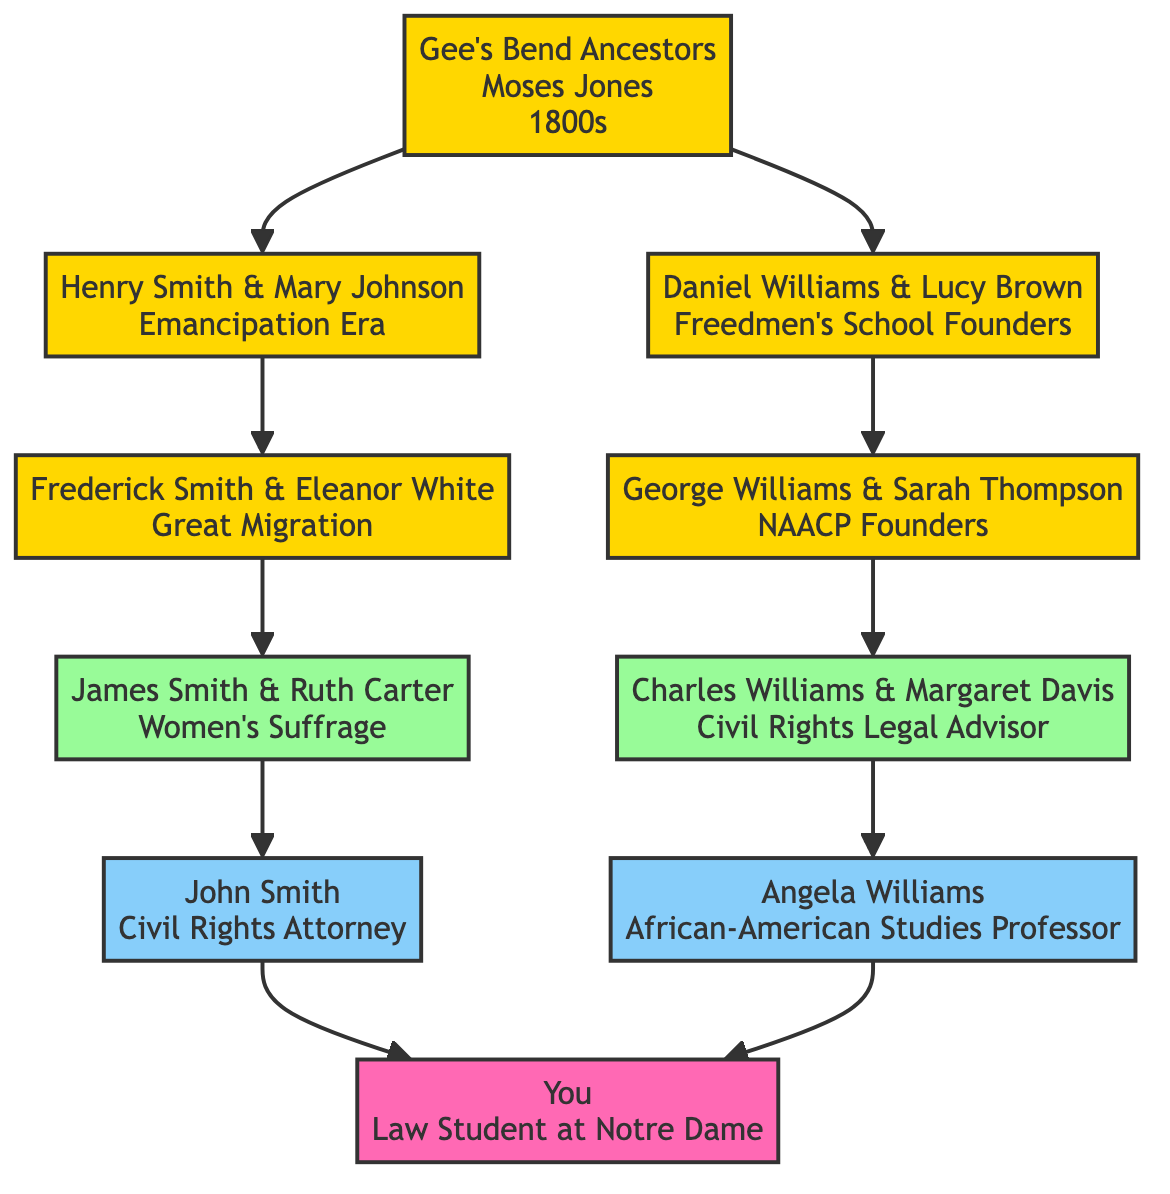What notable achievement is associated with John Smith? The diagram shows that John Smith is a Civil Rights attorney involved in landmark cases for racial equality. This information is derived from his individual node within the Parents section of the tree.
Answer: Civil Rights attorney Who are the Great-Grandparents on the maternal side? The Great-Grandparents section lists George Williams and Sarah Thompson as the maternal Great-Grandparents. You can find this by looking at the maternal branch under the Great-Grandparents in the diagram.
Answer: George Williams and Sarah Thompson How many nodes are in the diagram? The diagram includes 11 nodes in total, representing the different generations and notable individuals in the family tree. This total is calculated by counting each individual and merged node in the visual representation.
Answer: 11 What is the notable achievement of Ruth Carter? The diagram indicates that Ruth Carter was involved in the women’s suffrage movement and was an early voting rights advocate, which is detailed in her individual node in the Grandparents section.
Answer: Women's suffrage movement Which ancestor was involved in founding a freedmen's school? The diagram cites Daniel Williams and Lucy Brown in the Great-Great-Grandparents section as the founders of a freedmen's school in Mississippi. This can be identified by referencing the notable achievements listed alongside their names.
Answer: Daniel Williams and Lucy Brown What is the relationship between James Smith and Ruth Carter? James Smith and Ruth Carter are Grandparents; specifically, they are in the Grandparents section as a couple. This relationship is evident by their joint representation in the diagram.
Answer: Grandparents Who is the student studying law? The student node clearly identifies "You" as the law student at Notre Dame, making it straightforward to find this information in the bottom node of the diagram.
Answer: You What significant event did Frederick Smith and Eleanor White participate in? According to the diagram, Frederick Smith and Eleanor White participated in the Great Migration, which is documented in their node under the Great-Grandparents section.
Answer: Great Migration How are the Great-Great-Grandparents connected to the Gee's Bend Ancestors? The Great-Great-Grandparents (Henry Smith & Mary Johnson and Daniel Williams & Lucy Brown) are connected as descendants of the Gee's Bend Ancestors (Moses Jones), which can be determined by tracing the diagram from the ancestral node down through the generations.
Answer: Descendants 